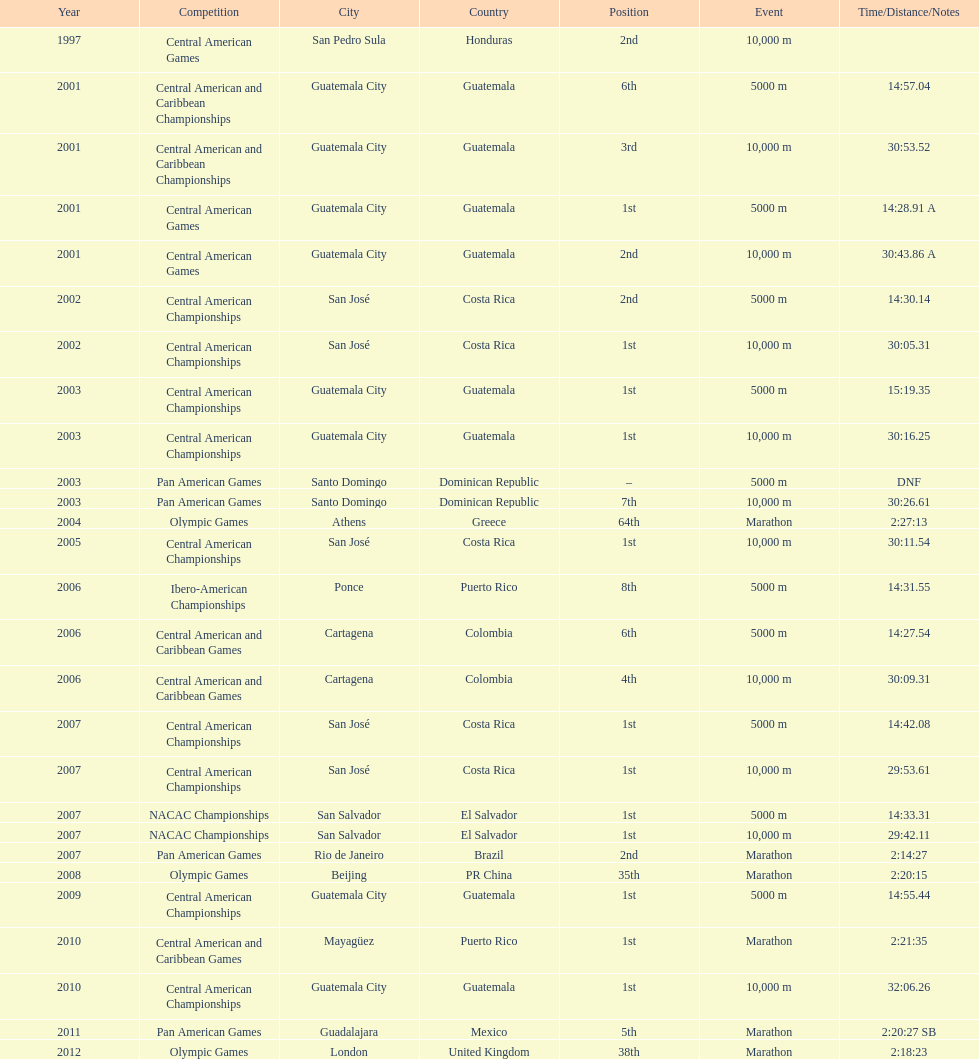What was the last competition in which a position of "2nd" was achieved? Pan American Games. 